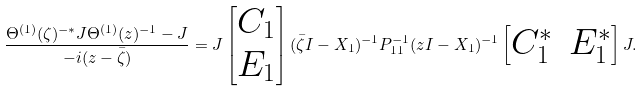Convert formula to latex. <formula><loc_0><loc_0><loc_500><loc_500>\frac { \Theta ^ { ( 1 ) } ( \zeta ) ^ { - * } J \Theta ^ { ( 1 ) } ( z ) ^ { - 1 } - J } { - i ( z - \bar { \zeta } ) } = J \begin{bmatrix} C _ { 1 } \\ E _ { 1 } \end{bmatrix} ( \bar { \zeta } I - X _ { 1 } ) ^ { - 1 } P _ { 1 1 } ^ { - 1 } ( z I - X _ { 1 } ) ^ { - 1 } \begin{bmatrix} C _ { 1 } ^ { * } & E _ { 1 } ^ { * } \end{bmatrix} J .</formula> 